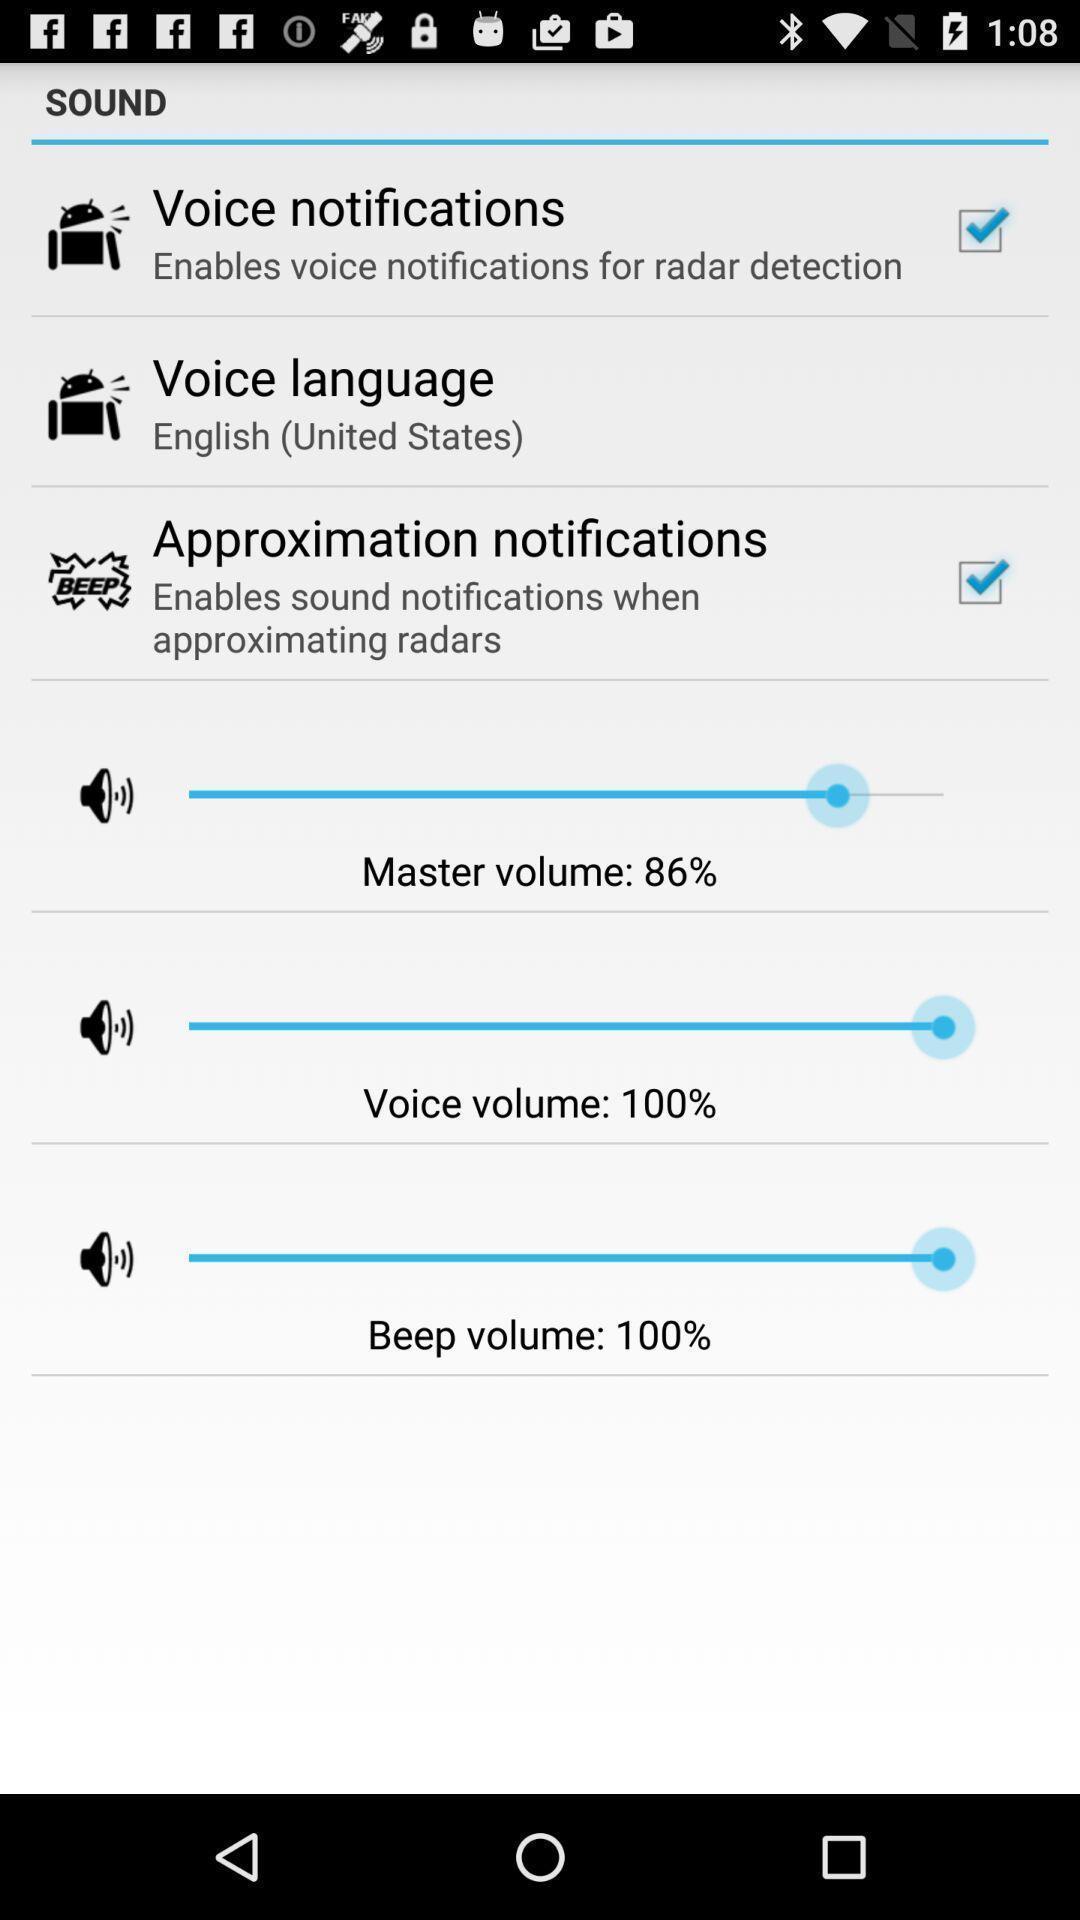Summarize the information in this screenshot. Sound settings page. 